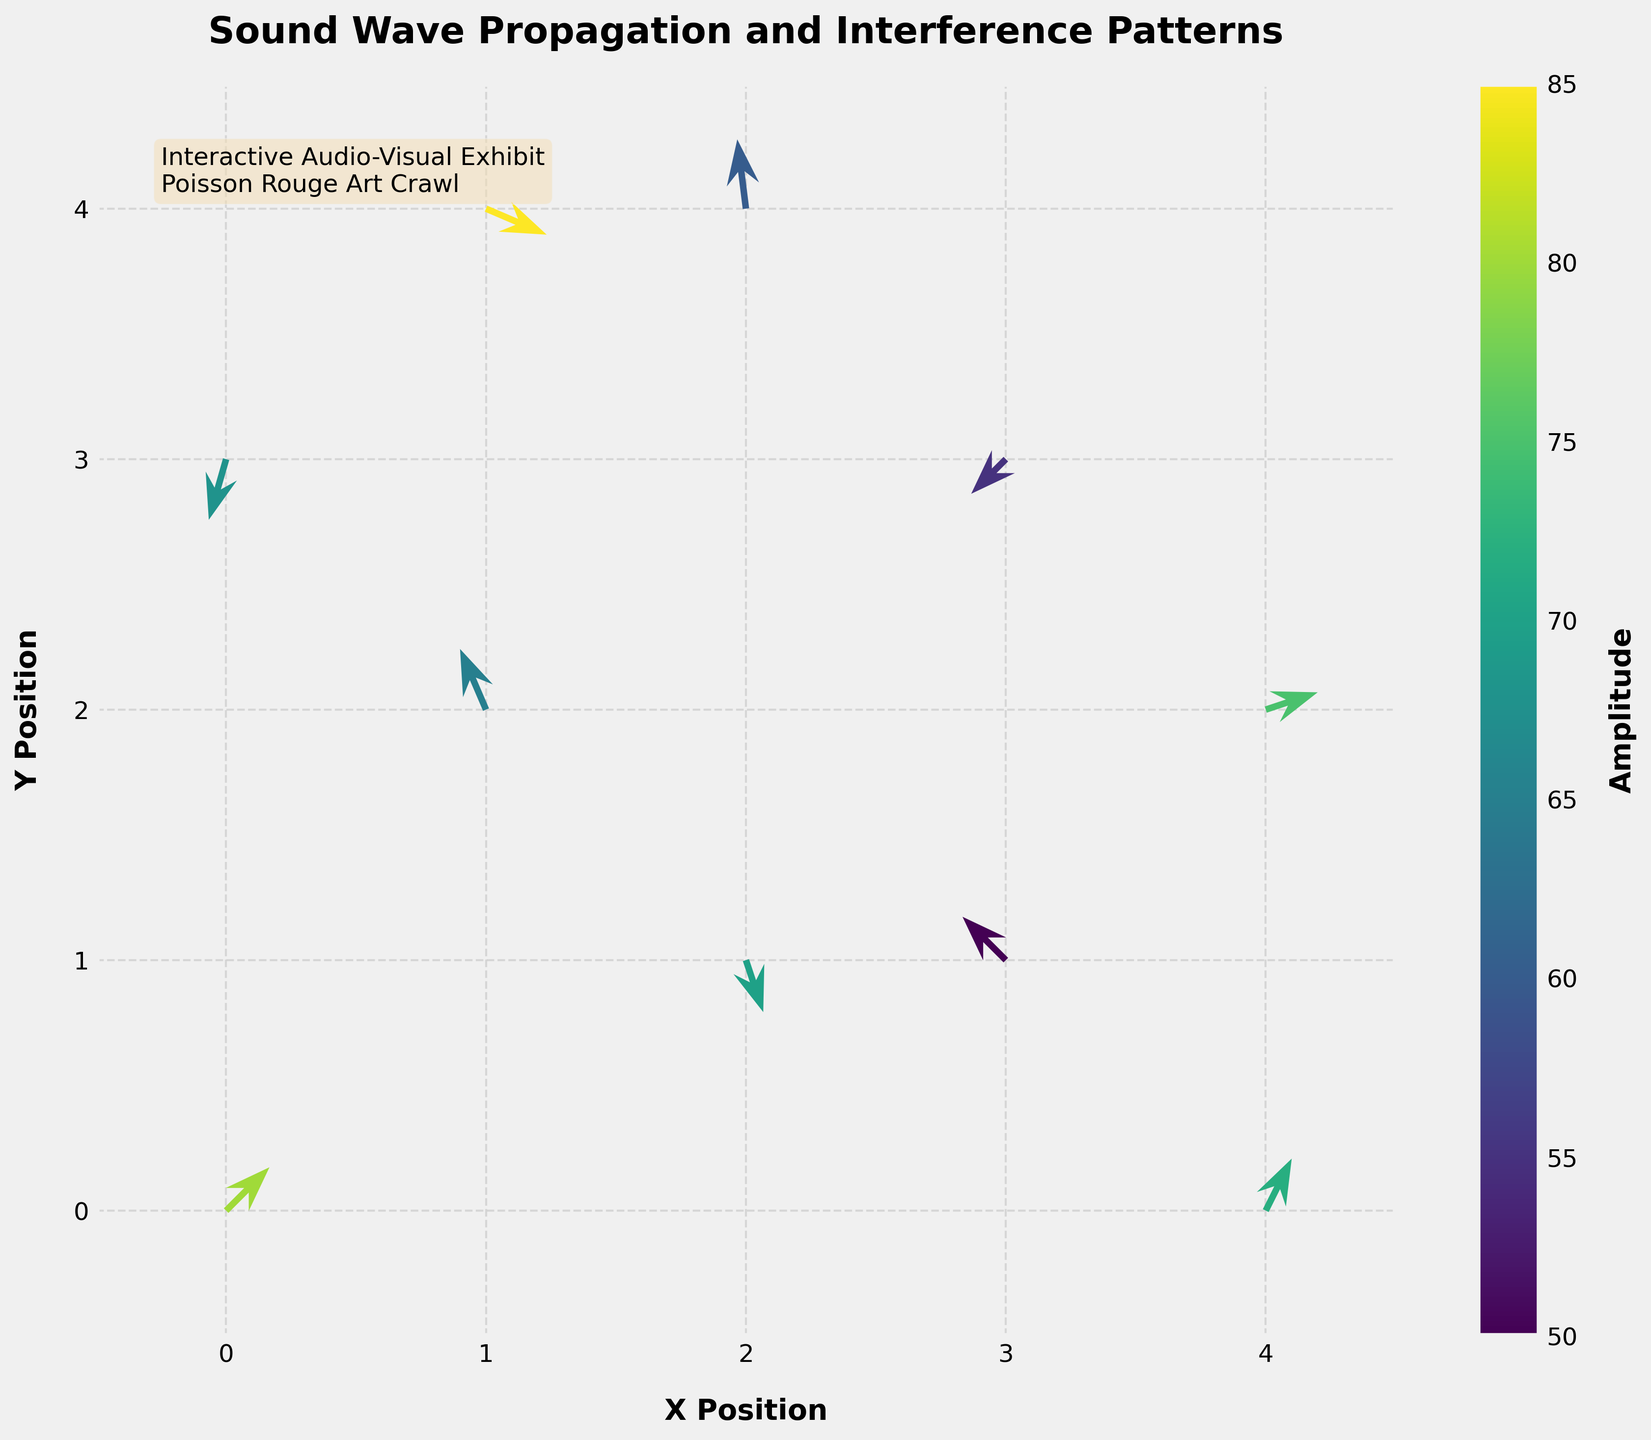what's the title of the plot? The title is displayed at the top center of the plot. It gives an overview of what the plot is about.
Answer: "Sound Wave Propagation and Interference Patterns" What's the label of the color bar, and what does it represent? The label is located on the color bar's vertical axis and indicates what the color gradient represents, which in this case is the amplitude of the sound waves.
Answer: Amplitude What's the range of x positions shown in the plot? The axis limits are usually indicated around the edges of the plot. In this case, the x-axis ranges from -0.5 to 4.5.
Answer: -0.5 to 4.5 How many data points have a positive x-component (u)? A positive x-component means the u value is greater than 0. You need to count the arrows with positive u values.
Answer: 5 At which position do you find the arrow with the highest amplitude, and what is its direction? The highest amplitude is indicated by the color bar. You locate the arrow with the deepest corresponding color and check its position and direction. The arrow with the highest amplitude (85) is at (1, 4), with a direction (0.7, -0.3).
Answer: Position: (1, 4), Direction: (0.7, -0.3) How does the amplitude vary across the plot? By examining the color gradient of the arrows, you can see how the amplitude changes from one arrow to another. Most arrows range in color between a certain gradient that corresponds to their amplitude values.
Answer: The amplitude varies from 50 to 85 Which arrow has the shortest vector length, and what's its position? The vector length can be determined by the magnitude of the vector (u, v), calculated as √(u² + v²). You compare lengths to find the shortest one, which has a relatively small magnitude.
Answer: The arrow at (2, 1) with vector (0.2, -0.6) What's the overall trend of sound wave propagation in terms of direction? By looking at the orientation of all vectors (arrows), you can determine the general directional pattern of sound wave propagation in the quiver plot.
Answer: There is no uniform directional trend; vectors point in various directions 